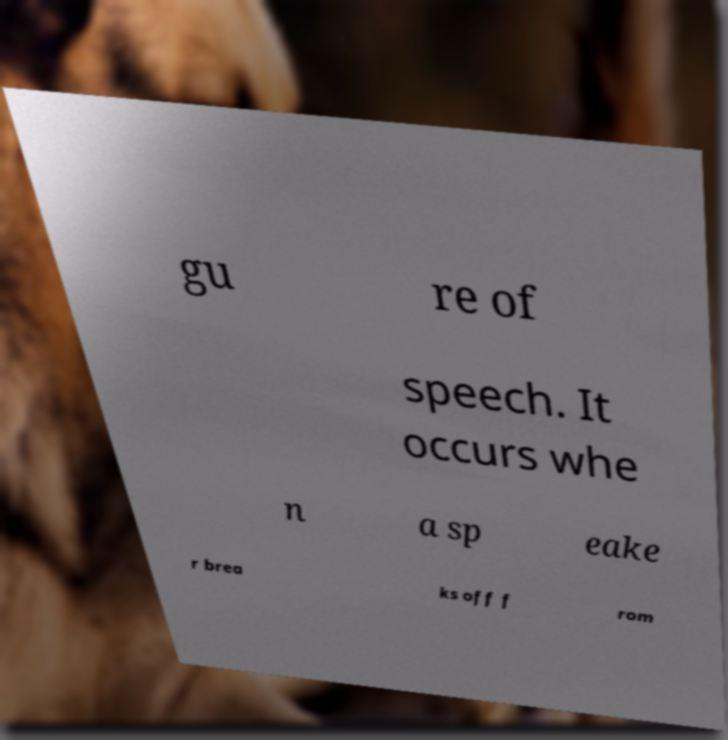Can you read and provide the text displayed in the image?This photo seems to have some interesting text. Can you extract and type it out for me? gu re of speech. It occurs whe n a sp eake r brea ks off f rom 